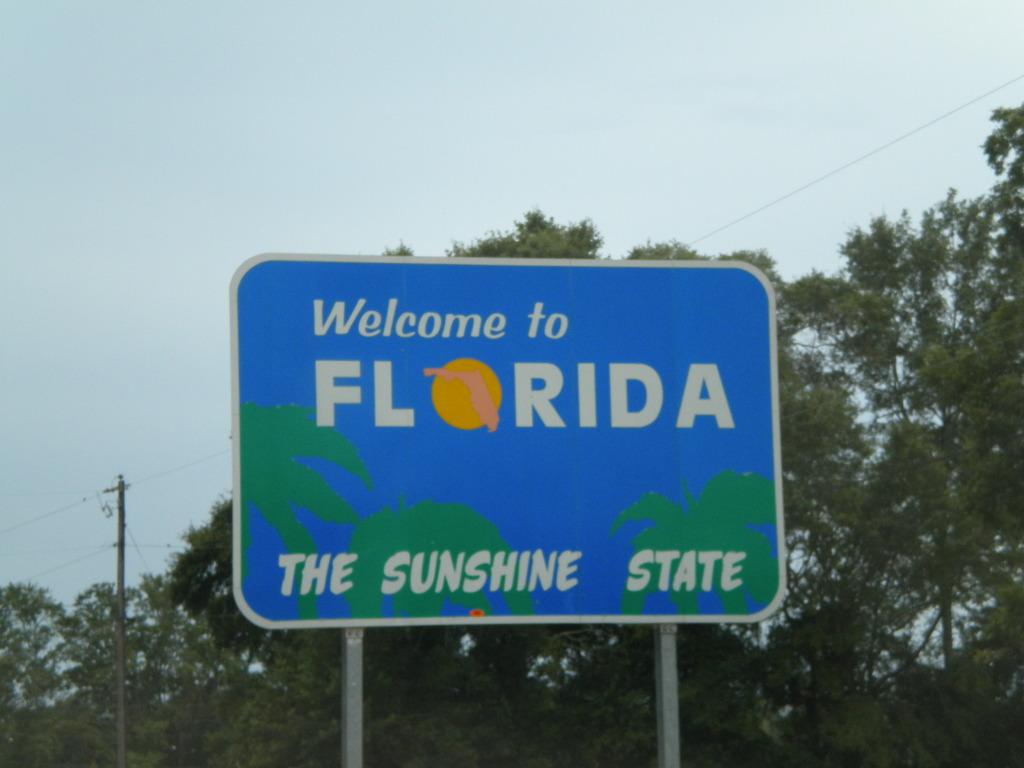What state is this?
Keep it short and to the point. Florida. What is florida known as?
Keep it short and to the point. The sunshine state. 